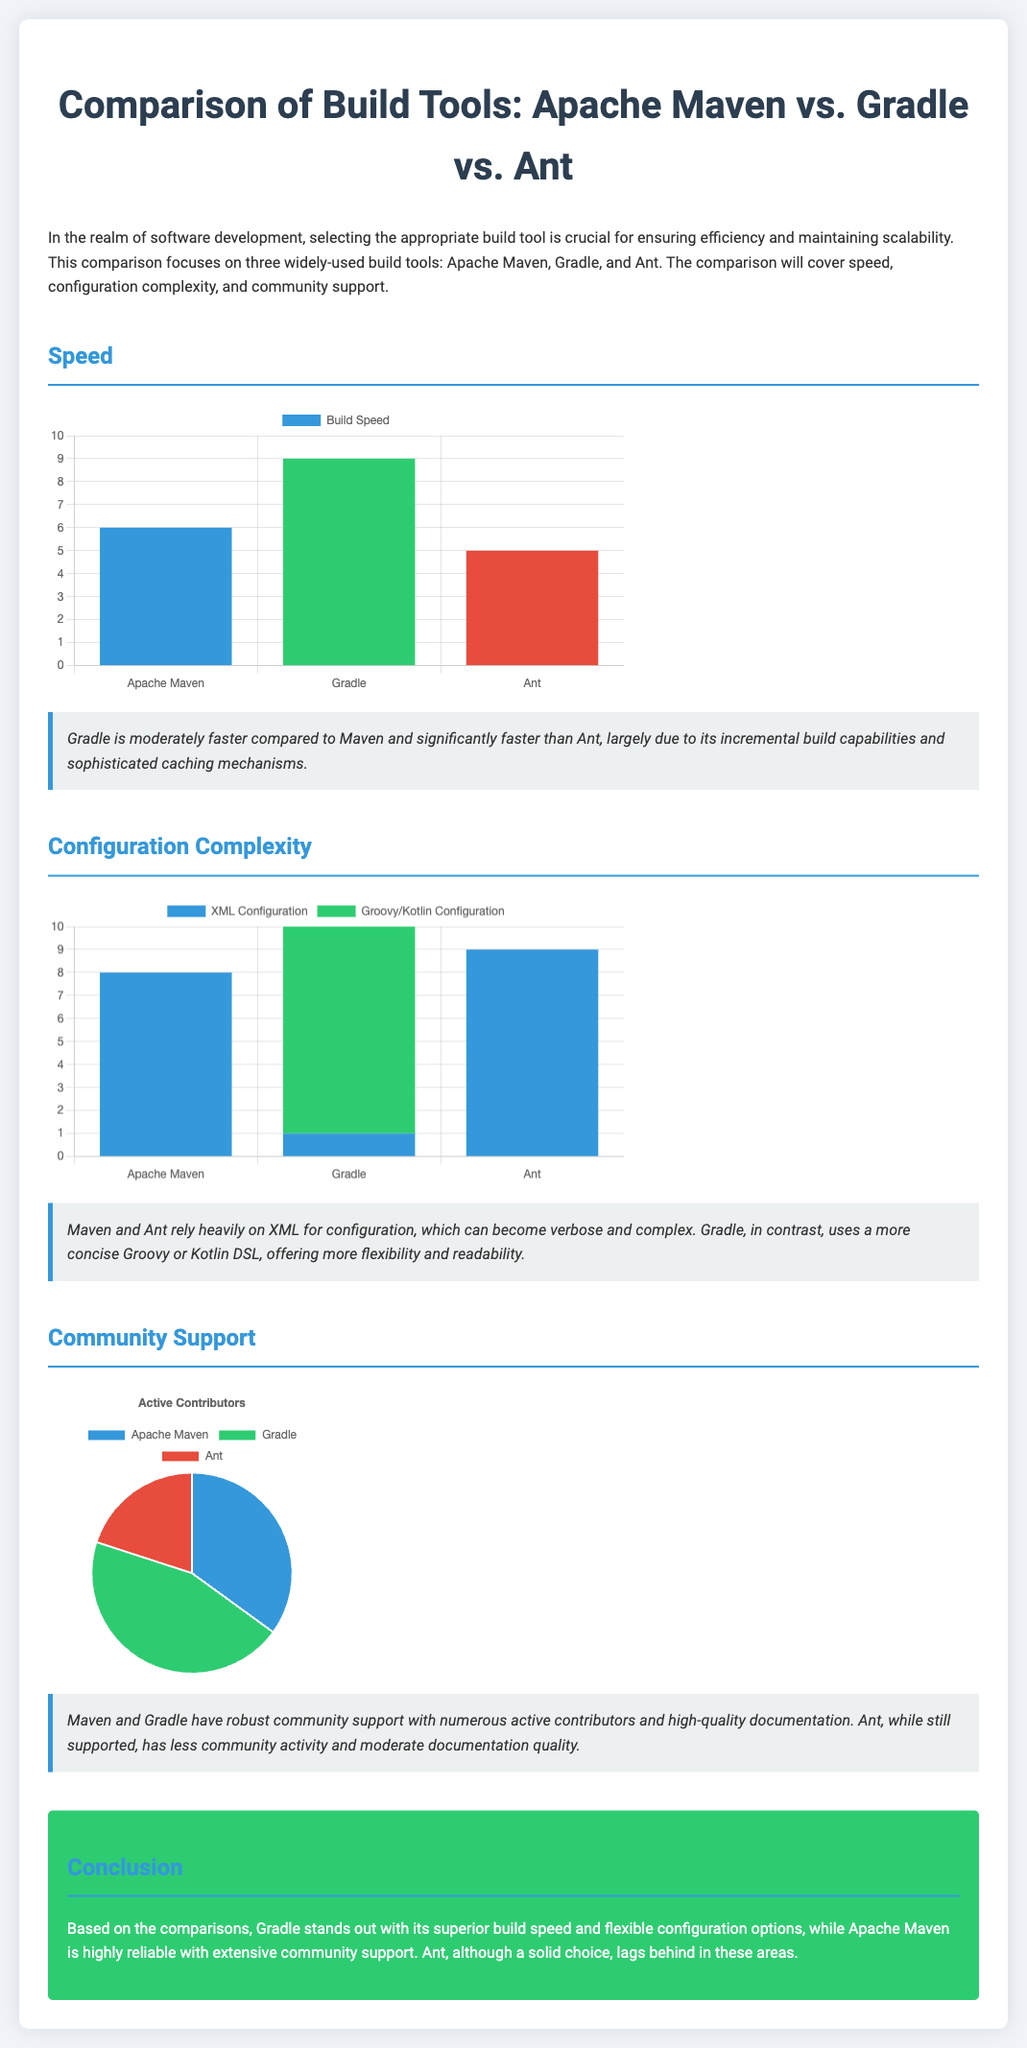What tool is the fastest according to the speed chart? The speed chart indicates that Gradle has the highest score of 9, making it the fastest among the three tools.
Answer: Gradle What configuration complexity score does Apache Maven have? The complexity chart shows that Apache Maven has a score of 8 for XML configuration.
Answer: 8 Which tool has a score of 9 for Groovy/Kotlin configuration? According to the complexity chart, Gradle has a score of 9 for Groovy/Kotlin configuration.
Answer: Gradle What percentage of the community support does Gradle have? The community support chart indicates that Gradle represents 45% of active contributors.
Answer: 45% Which build tool relies heavily on XML for configuration? The document states that both Apache Maven and Ant rely heavily on XML for configuration.
Answer: Apache Maven and Ant Which tool is noted for its incremental build capabilities? The notes under the speed section highlight that Gradle is noted for its incremental build capabilities.
Answer: Gradle How many build tools are compared in the infographic? The document specifies three build tools being compared: Apache Maven, Gradle, and Ant.
Answer: Three What is the main conclusion regarding the build tools? The conclusion section summarizes that Gradle stands out for its speed and flexibility, while Maven is reliable.
Answer: Gradle stands out What aspect of Ant has been noted in terms of community activity? The notes mention that Ant has less community activity compared to Maven and Gradle.
Answer: Less community activity 